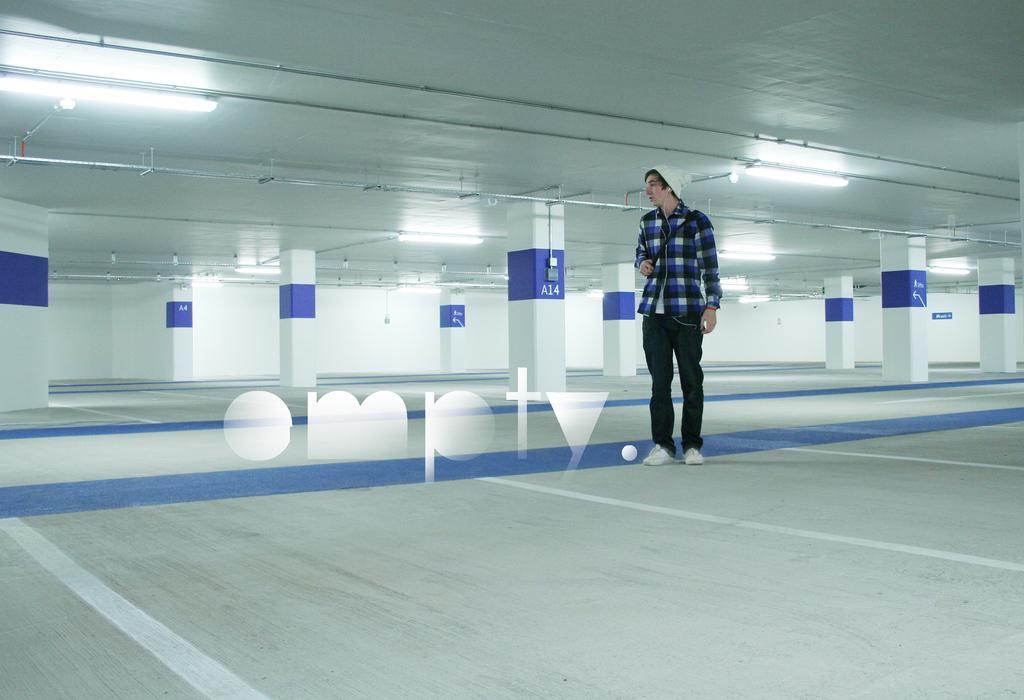How would you summarize this image in a sentence or two? In this image, we can see a person standing. We can also see the ground. We can see the wall and the roof with some lights. We can see some pillars with text written. We can also see a watermark on the image. 